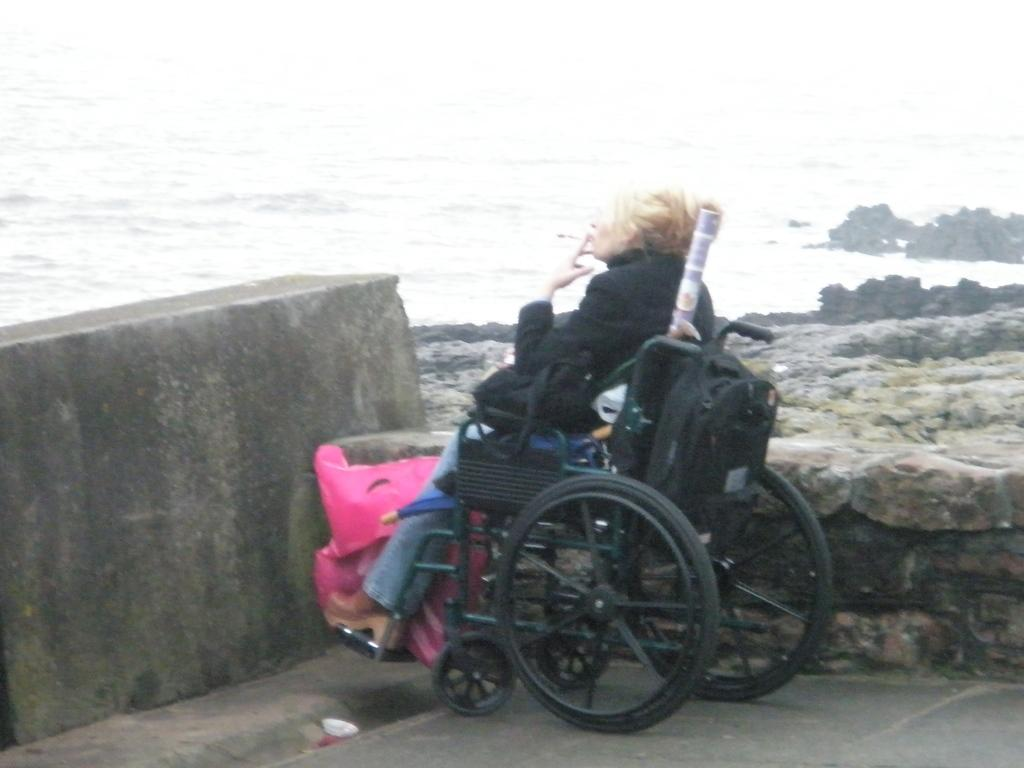What is the person in the image using to sit? There is a person sitting on a wheelchair in the image. What color is the cover visible in the image? There is a pink color cover in the image. What can be seen behind the person in the image? There is a wall in the image. What type of natural environment is visible in the background of the image? The background of the image includes water and rocks. What hobbies does the minister have, as seen in the image? There is no minister present in the image, and therefore no hobbies can be observed. How are the rocks sorted in the image? There is no indication in the image that the rocks are being sorted. 